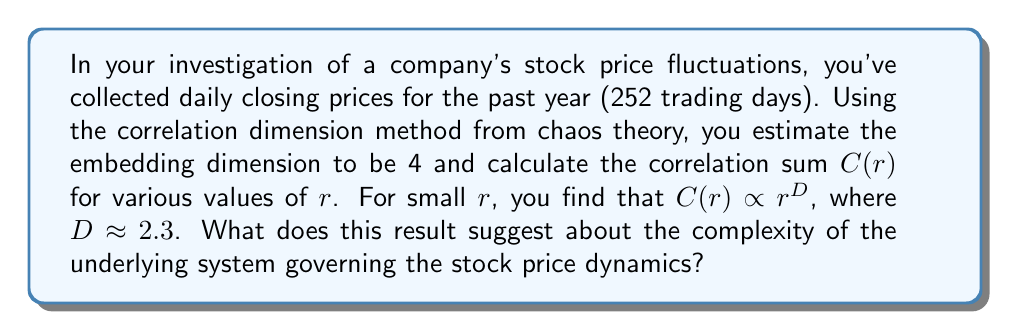Teach me how to tackle this problem. To interpret this result, we need to understand the correlation dimension in the context of financial time series:

1. Embedding dimension: The embedding dimension of 4 suggests that we need at least 4 variables to describe the system's state space adequately.

2. Correlation sum $C(r)$: This function measures the probability that two points in the phase space are closer than a distance $r$.

3. Correlation dimension $D$: The power law relationship $C(r) \propto r^D$ for small $r$ allows us to estimate the correlation dimension $D$.

4. Interpretation of $D$:
   - If $D$ is an integer, it often indicates a simple, deterministic system.
   - Non-integer $D$ suggests fractal structure, often associated with chaotic systems.
   - $D$ less than the embedding dimension indicates the presence of an attractor.

5. In this case, $D \approx 2.3$:
   - It's a non-integer, suggesting fractal structure.
   - It's less than the embedding dimension (4), indicating an attractor.
   - 2.3 is between 2 and 3, suggesting more complexity than a 2D system but not fully 3D.

6. Financial interpretation:
   - The non-integer dimension suggests the stock price dynamics are not purely random.
   - The system shows signs of deterministic chaos, with some underlying structure.
   - The complexity is higher than a simple trend or cycle but not as complex as a fully random walk.

This result indicates that the stock price dynamics exhibit characteristics of a low-dimensional chaotic system, with some predictable patterns amidst apparent randomness.
Answer: The correlation dimension of 2.3 suggests the stock price dynamics exhibit low-dimensional chaos, indicating complex but not entirely random behavior. 